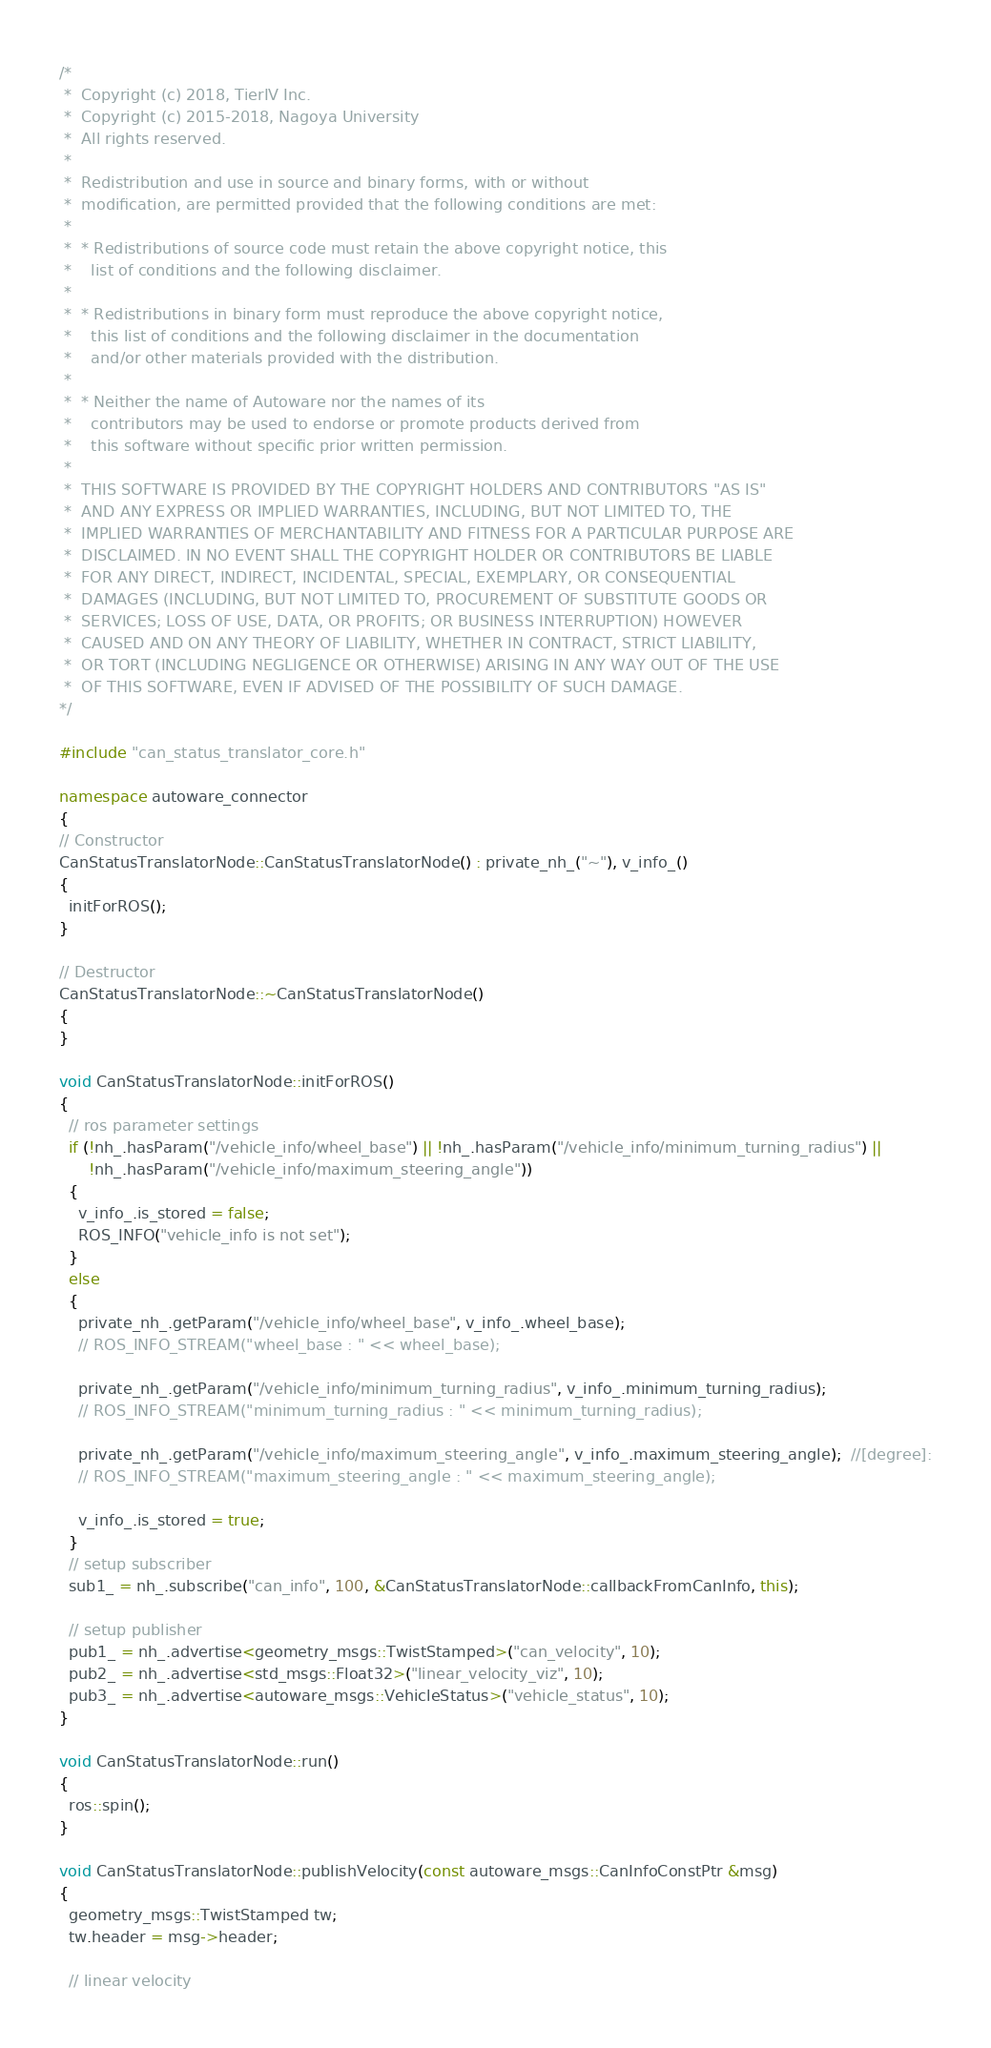<code> <loc_0><loc_0><loc_500><loc_500><_C++_>/*
 *  Copyright (c) 2018, TierIV Inc.
 *  Copyright (c) 2015-2018, Nagoya University
 *  All rights reserved.
 *
 *  Redistribution and use in source and binary forms, with or without
 *  modification, are permitted provided that the following conditions are met:
 *
 *  * Redistributions of source code must retain the above copyright notice, this
 *    list of conditions and the following disclaimer.
 *
 *  * Redistributions in binary form must reproduce the above copyright notice,
 *    this list of conditions and the following disclaimer in the documentation
 *    and/or other materials provided with the distribution.
 *
 *  * Neither the name of Autoware nor the names of its
 *    contributors may be used to endorse or promote products derived from
 *    this software without specific prior written permission.
 *
 *  THIS SOFTWARE IS PROVIDED BY THE COPYRIGHT HOLDERS AND CONTRIBUTORS "AS IS"
 *  AND ANY EXPRESS OR IMPLIED WARRANTIES, INCLUDING, BUT NOT LIMITED TO, THE
 *  IMPLIED WARRANTIES OF MERCHANTABILITY AND FITNESS FOR A PARTICULAR PURPOSE ARE
 *  DISCLAIMED. IN NO EVENT SHALL THE COPYRIGHT HOLDER OR CONTRIBUTORS BE LIABLE
 *  FOR ANY DIRECT, INDIRECT, INCIDENTAL, SPECIAL, EXEMPLARY, OR CONSEQUENTIAL
 *  DAMAGES (INCLUDING, BUT NOT LIMITED TO, PROCUREMENT OF SUBSTITUTE GOODS OR
 *  SERVICES; LOSS OF USE, DATA, OR PROFITS; OR BUSINESS INTERRUPTION) HOWEVER
 *  CAUSED AND ON ANY THEORY OF LIABILITY, WHETHER IN CONTRACT, STRICT LIABILITY,
 *  OR TORT (INCLUDING NEGLIGENCE OR OTHERWISE) ARISING IN ANY WAY OUT OF THE USE
 *  OF THIS SOFTWARE, EVEN IF ADVISED OF THE POSSIBILITY OF SUCH DAMAGE.
*/

#include "can_status_translator_core.h"

namespace autoware_connector
{
// Constructor
CanStatusTranslatorNode::CanStatusTranslatorNode() : private_nh_("~"), v_info_()
{
  initForROS();
}

// Destructor
CanStatusTranslatorNode::~CanStatusTranslatorNode()
{
}

void CanStatusTranslatorNode::initForROS()
{
  // ros parameter settings
  if (!nh_.hasParam("/vehicle_info/wheel_base") || !nh_.hasParam("/vehicle_info/minimum_turning_radius") ||
      !nh_.hasParam("/vehicle_info/maximum_steering_angle"))
  {
    v_info_.is_stored = false;
    ROS_INFO("vehicle_info is not set");
  }
  else
  {
    private_nh_.getParam("/vehicle_info/wheel_base", v_info_.wheel_base);
    // ROS_INFO_STREAM("wheel_base : " << wheel_base);

    private_nh_.getParam("/vehicle_info/minimum_turning_radius", v_info_.minimum_turning_radius);
    // ROS_INFO_STREAM("minimum_turning_radius : " << minimum_turning_radius);

    private_nh_.getParam("/vehicle_info/maximum_steering_angle", v_info_.maximum_steering_angle);  //[degree]:
    // ROS_INFO_STREAM("maximum_steering_angle : " << maximum_steering_angle);

    v_info_.is_stored = true;
  }
  // setup subscriber
  sub1_ = nh_.subscribe("can_info", 100, &CanStatusTranslatorNode::callbackFromCanInfo, this);

  // setup publisher
  pub1_ = nh_.advertise<geometry_msgs::TwistStamped>("can_velocity", 10);
  pub2_ = nh_.advertise<std_msgs::Float32>("linear_velocity_viz", 10);
  pub3_ = nh_.advertise<autoware_msgs::VehicleStatus>("vehicle_status", 10);
}

void CanStatusTranslatorNode::run()
{
  ros::spin();
}

void CanStatusTranslatorNode::publishVelocity(const autoware_msgs::CanInfoConstPtr &msg)
{
  geometry_msgs::TwistStamped tw;
  tw.header = msg->header;

  // linear velocity</code> 